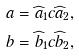Convert formula to latex. <formula><loc_0><loc_0><loc_500><loc_500>& a = \widehat { a } _ { 1 } c \widehat { a } _ { 2 } , \\ & b = \widehat { b } _ { 1 } c \widehat { b } _ { 2 } ,</formula> 